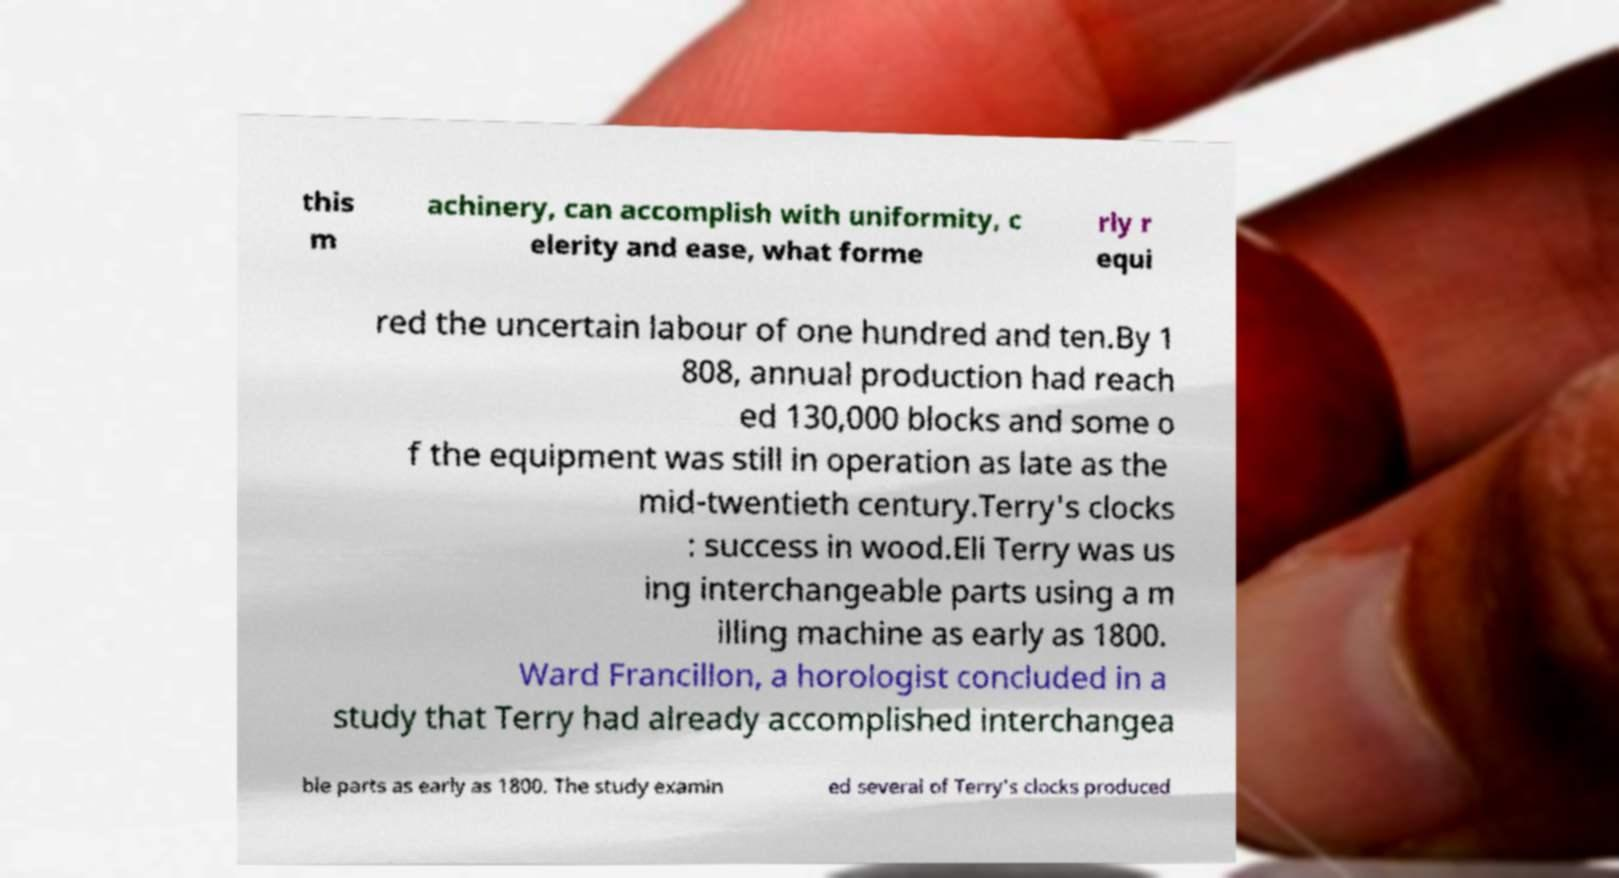Please read and relay the text visible in this image. What does it say? this m achinery, can accomplish with uniformity, c elerity and ease, what forme rly r equi red the uncertain labour of one hundred and ten.By 1 808, annual production had reach ed 130,000 blocks and some o f the equipment was still in operation as late as the mid-twentieth century.Terry's clocks : success in wood.Eli Terry was us ing interchangeable parts using a m illing machine as early as 1800. Ward Francillon, a horologist concluded in a study that Terry had already accomplished interchangea ble parts as early as 1800. The study examin ed several of Terry's clocks produced 